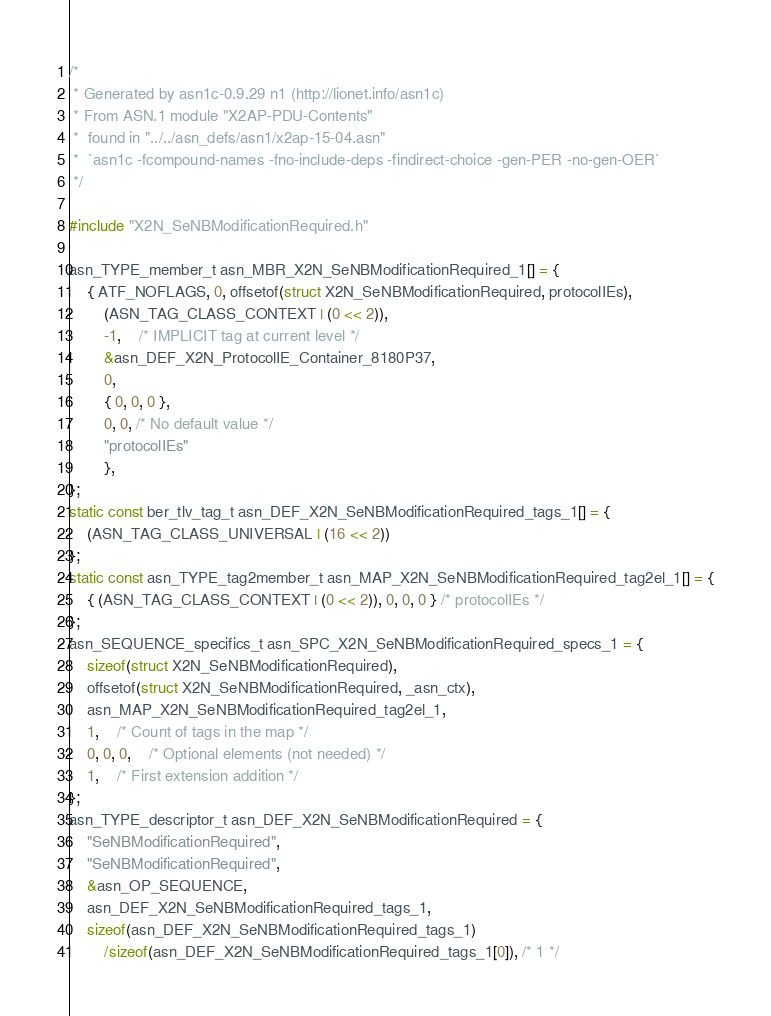<code> <loc_0><loc_0><loc_500><loc_500><_C_>/*
 * Generated by asn1c-0.9.29 n1 (http://lionet.info/asn1c)
 * From ASN.1 module "X2AP-PDU-Contents"
 * 	found in "../../asn_defs/asn1/x2ap-15-04.asn"
 * 	`asn1c -fcompound-names -fno-include-deps -findirect-choice -gen-PER -no-gen-OER`
 */

#include "X2N_SeNBModificationRequired.h"

asn_TYPE_member_t asn_MBR_X2N_SeNBModificationRequired_1[] = {
	{ ATF_NOFLAGS, 0, offsetof(struct X2N_SeNBModificationRequired, protocolIEs),
		(ASN_TAG_CLASS_CONTEXT | (0 << 2)),
		-1,	/* IMPLICIT tag at current level */
		&asn_DEF_X2N_ProtocolIE_Container_8180P37,
		0,
		{ 0, 0, 0 },
		0, 0, /* No default value */
		"protocolIEs"
		},
};
static const ber_tlv_tag_t asn_DEF_X2N_SeNBModificationRequired_tags_1[] = {
	(ASN_TAG_CLASS_UNIVERSAL | (16 << 2))
};
static const asn_TYPE_tag2member_t asn_MAP_X2N_SeNBModificationRequired_tag2el_1[] = {
    { (ASN_TAG_CLASS_CONTEXT | (0 << 2)), 0, 0, 0 } /* protocolIEs */
};
asn_SEQUENCE_specifics_t asn_SPC_X2N_SeNBModificationRequired_specs_1 = {
	sizeof(struct X2N_SeNBModificationRequired),
	offsetof(struct X2N_SeNBModificationRequired, _asn_ctx),
	asn_MAP_X2N_SeNBModificationRequired_tag2el_1,
	1,	/* Count of tags in the map */
	0, 0, 0,	/* Optional elements (not needed) */
	1,	/* First extension addition */
};
asn_TYPE_descriptor_t asn_DEF_X2N_SeNBModificationRequired = {
	"SeNBModificationRequired",
	"SeNBModificationRequired",
	&asn_OP_SEQUENCE,
	asn_DEF_X2N_SeNBModificationRequired_tags_1,
	sizeof(asn_DEF_X2N_SeNBModificationRequired_tags_1)
		/sizeof(asn_DEF_X2N_SeNBModificationRequired_tags_1[0]), /* 1 */</code> 